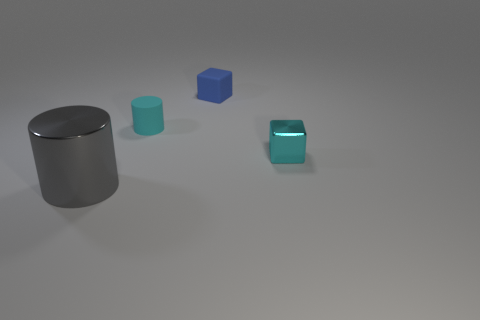What material is the big gray cylinder?
Give a very brief answer. Metal. How many small cyan objects are to the right of the small block that is in front of the tiny blue object?
Your response must be concise. 0. There is a small shiny object; is its color the same as the tiny rubber object that is on the left side of the blue matte thing?
Provide a succinct answer. Yes. The other matte block that is the same size as the cyan cube is what color?
Offer a very short reply. Blue. Are there any tiny cyan rubber things of the same shape as the tiny shiny object?
Ensure brevity in your answer.  No. Are there fewer large blue metal balls than cyan metallic objects?
Offer a terse response. Yes. There is a metallic thing that is behind the large gray cylinder; what is its color?
Offer a terse response. Cyan. There is a cyan thing behind the metallic thing that is behind the gray cylinder; what shape is it?
Keep it short and to the point. Cylinder. Do the small cyan block and the cylinder that is behind the large gray metallic object have the same material?
Ensure brevity in your answer.  No. What shape is the other object that is the same color as the small metal object?
Provide a short and direct response. Cylinder. 